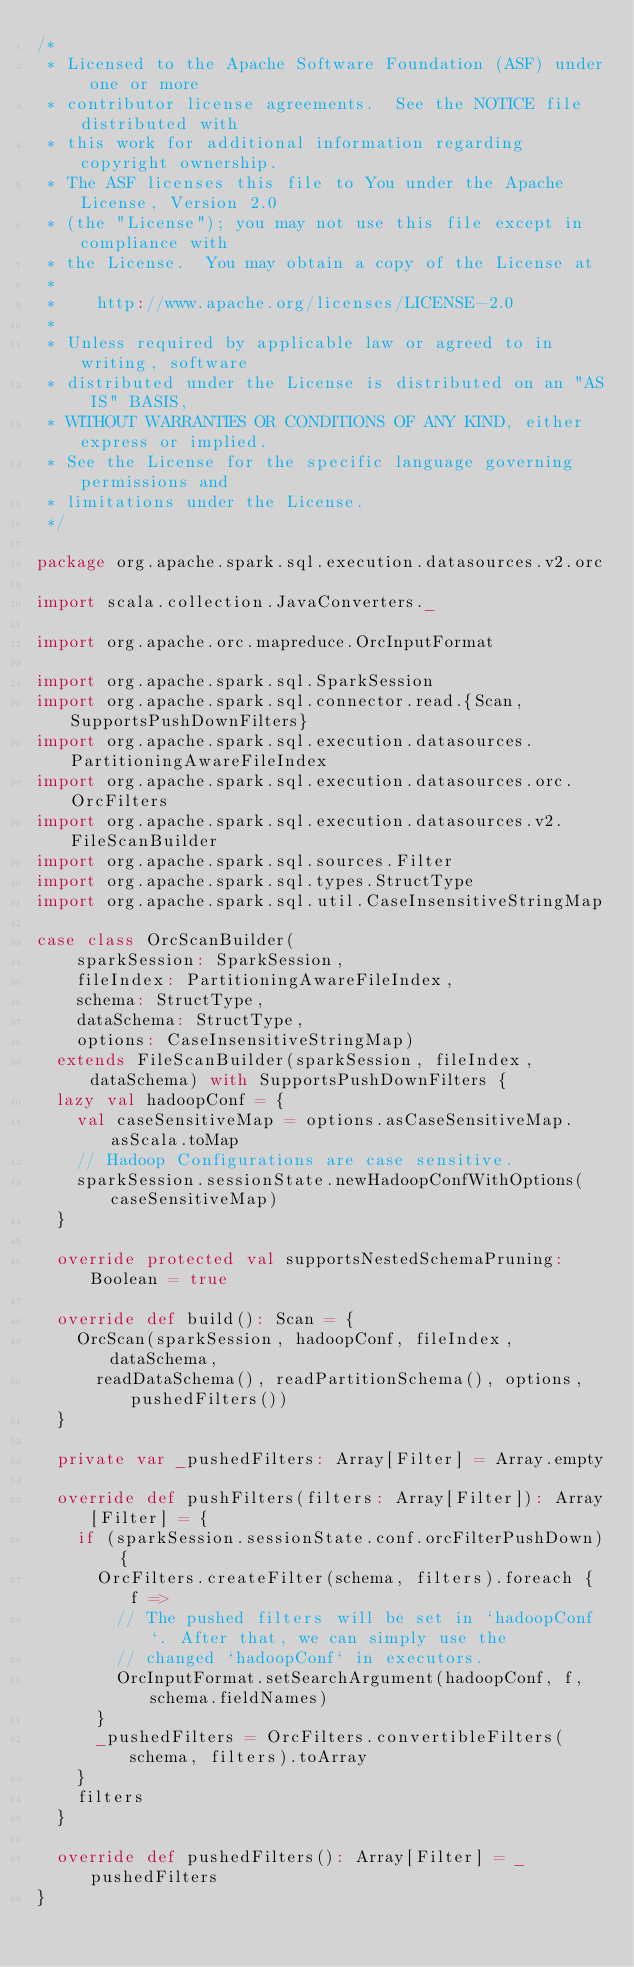Convert code to text. <code><loc_0><loc_0><loc_500><loc_500><_Scala_>/*
 * Licensed to the Apache Software Foundation (ASF) under one or more
 * contributor license agreements.  See the NOTICE file distributed with
 * this work for additional information regarding copyright ownership.
 * The ASF licenses this file to You under the Apache License, Version 2.0
 * (the "License"); you may not use this file except in compliance with
 * the License.  You may obtain a copy of the License at
 *
 *    http://www.apache.org/licenses/LICENSE-2.0
 *
 * Unless required by applicable law or agreed to in writing, software
 * distributed under the License is distributed on an "AS IS" BASIS,
 * WITHOUT WARRANTIES OR CONDITIONS OF ANY KIND, either express or implied.
 * See the License for the specific language governing permissions and
 * limitations under the License.
 */

package org.apache.spark.sql.execution.datasources.v2.orc

import scala.collection.JavaConverters._

import org.apache.orc.mapreduce.OrcInputFormat

import org.apache.spark.sql.SparkSession
import org.apache.spark.sql.connector.read.{Scan, SupportsPushDownFilters}
import org.apache.spark.sql.execution.datasources.PartitioningAwareFileIndex
import org.apache.spark.sql.execution.datasources.orc.OrcFilters
import org.apache.spark.sql.execution.datasources.v2.FileScanBuilder
import org.apache.spark.sql.sources.Filter
import org.apache.spark.sql.types.StructType
import org.apache.spark.sql.util.CaseInsensitiveStringMap

case class OrcScanBuilder(
    sparkSession: SparkSession,
    fileIndex: PartitioningAwareFileIndex,
    schema: StructType,
    dataSchema: StructType,
    options: CaseInsensitiveStringMap)
  extends FileScanBuilder(sparkSession, fileIndex, dataSchema) with SupportsPushDownFilters {
  lazy val hadoopConf = {
    val caseSensitiveMap = options.asCaseSensitiveMap.asScala.toMap
    // Hadoop Configurations are case sensitive.
    sparkSession.sessionState.newHadoopConfWithOptions(caseSensitiveMap)
  }

  override protected val supportsNestedSchemaPruning: Boolean = true

  override def build(): Scan = {
    OrcScan(sparkSession, hadoopConf, fileIndex, dataSchema,
      readDataSchema(), readPartitionSchema(), options, pushedFilters())
  }

  private var _pushedFilters: Array[Filter] = Array.empty

  override def pushFilters(filters: Array[Filter]): Array[Filter] = {
    if (sparkSession.sessionState.conf.orcFilterPushDown) {
      OrcFilters.createFilter(schema, filters).foreach { f =>
        // The pushed filters will be set in `hadoopConf`. After that, we can simply use the
        // changed `hadoopConf` in executors.
        OrcInputFormat.setSearchArgument(hadoopConf, f, schema.fieldNames)
      }
      _pushedFilters = OrcFilters.convertibleFilters(schema, filters).toArray
    }
    filters
  }

  override def pushedFilters(): Array[Filter] = _pushedFilters
}
</code> 